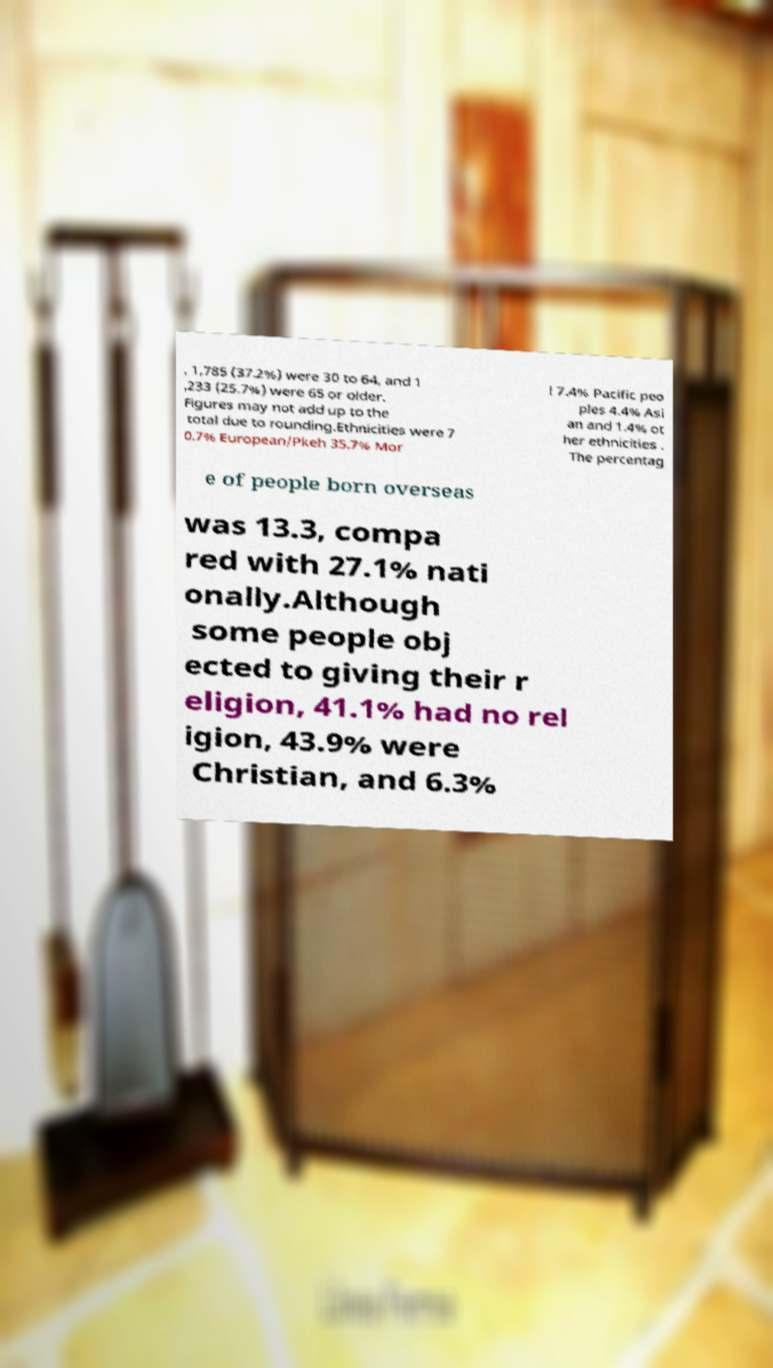Please read and relay the text visible in this image. What does it say? , 1,785 (37.2%) were 30 to 64, and 1 ,233 (25.7%) were 65 or older. Figures may not add up to the total due to rounding.Ethnicities were 7 0.7% European/Pkeh 35.7% Mor i 7.4% Pacific peo ples 4.4% Asi an and 1.4% ot her ethnicities . The percentag e of people born overseas was 13.3, compa red with 27.1% nati onally.Although some people obj ected to giving their r eligion, 41.1% had no rel igion, 43.9% were Christian, and 6.3% 